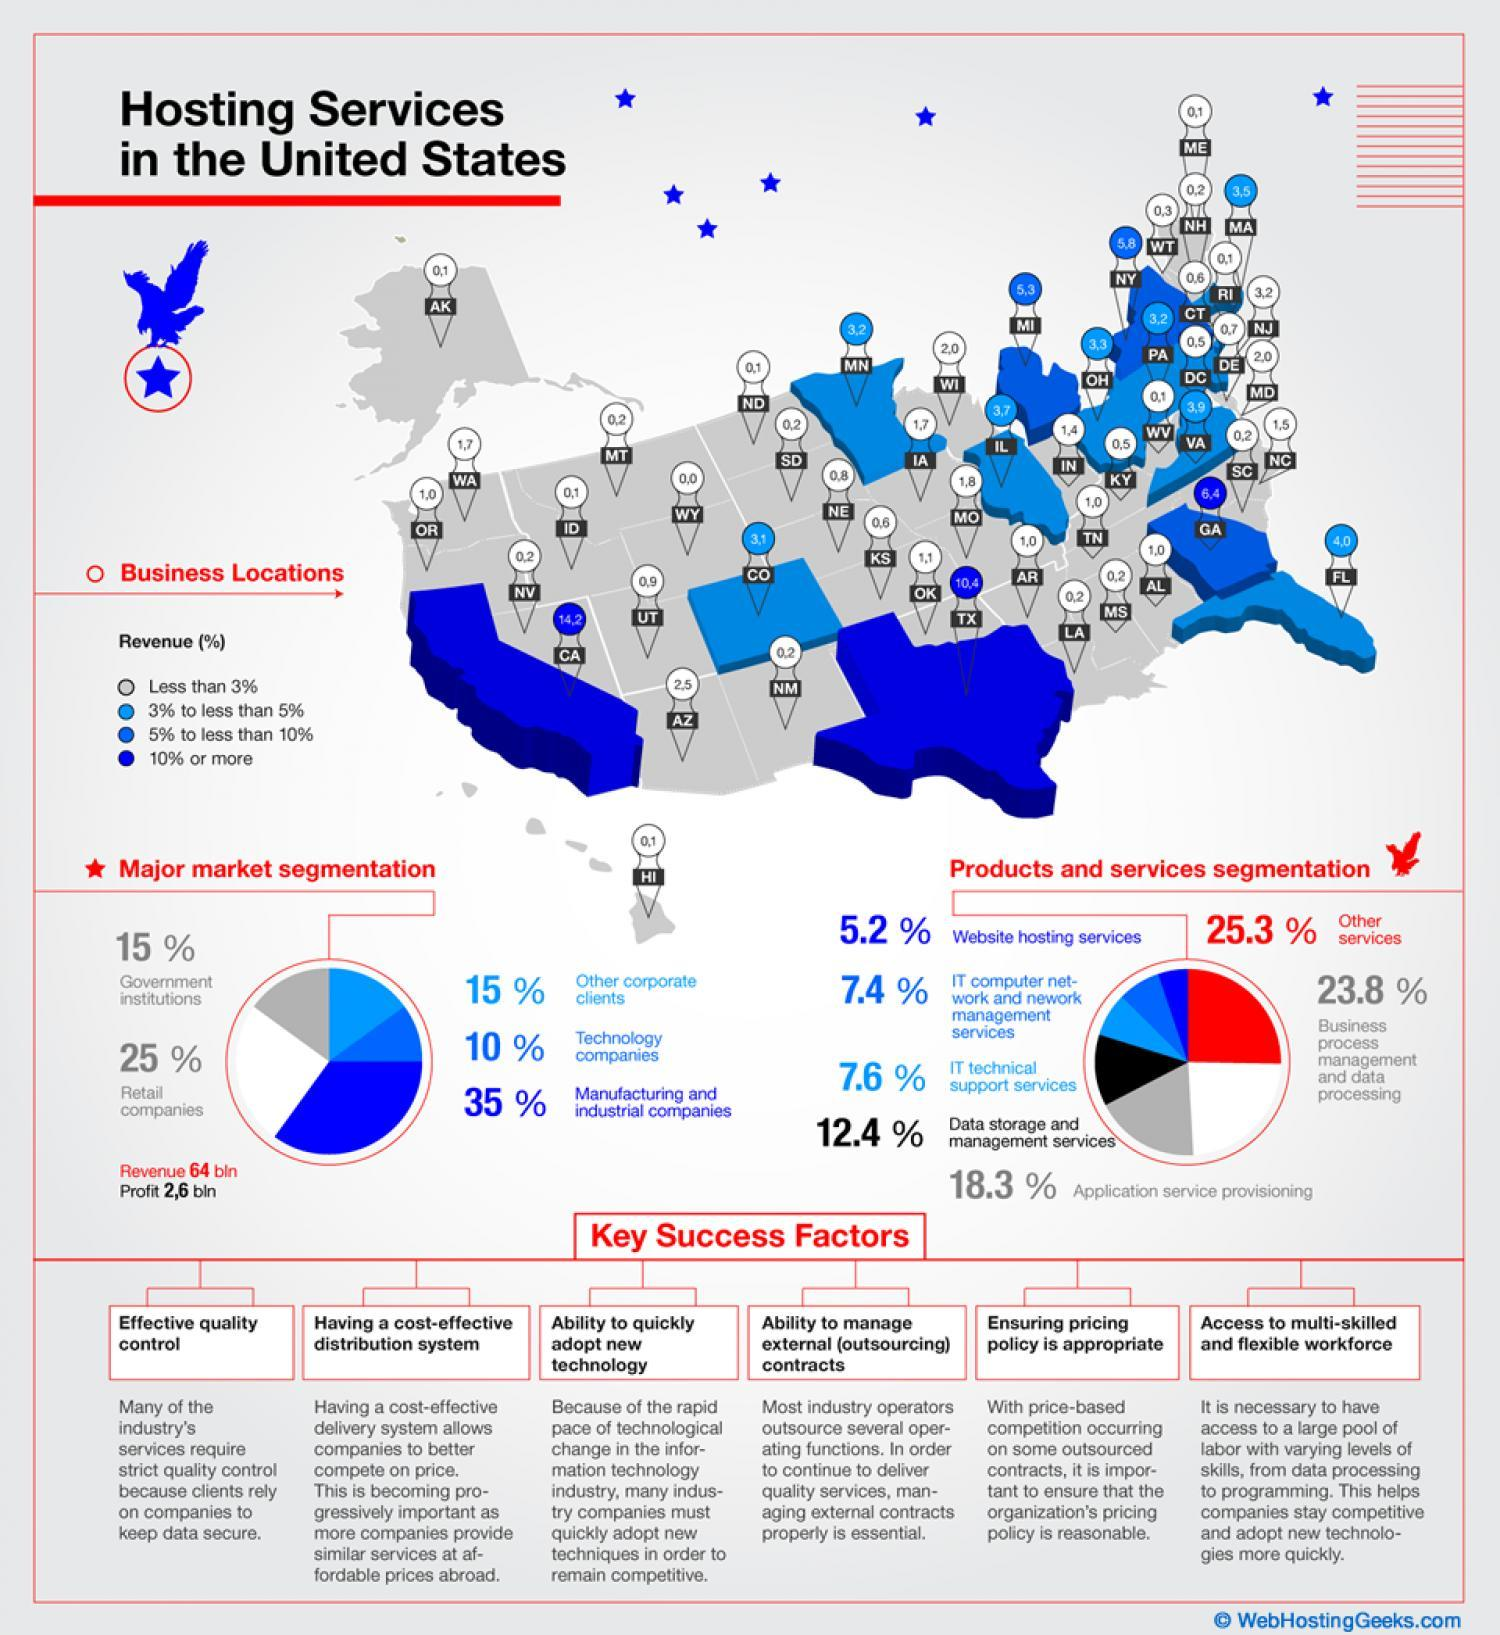How many locations have revenue of 10% or more?
Answer the question with a short phrase. 2 What percentage of market is occupied by technology companies and other corporate clients?? 25% How many factors listed are key to success? 6 Which products and services is third largest in the pie chart? Application service provisioning 